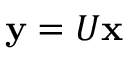<formula> <loc_0><loc_0><loc_500><loc_500>{ y } = U { x }</formula> 